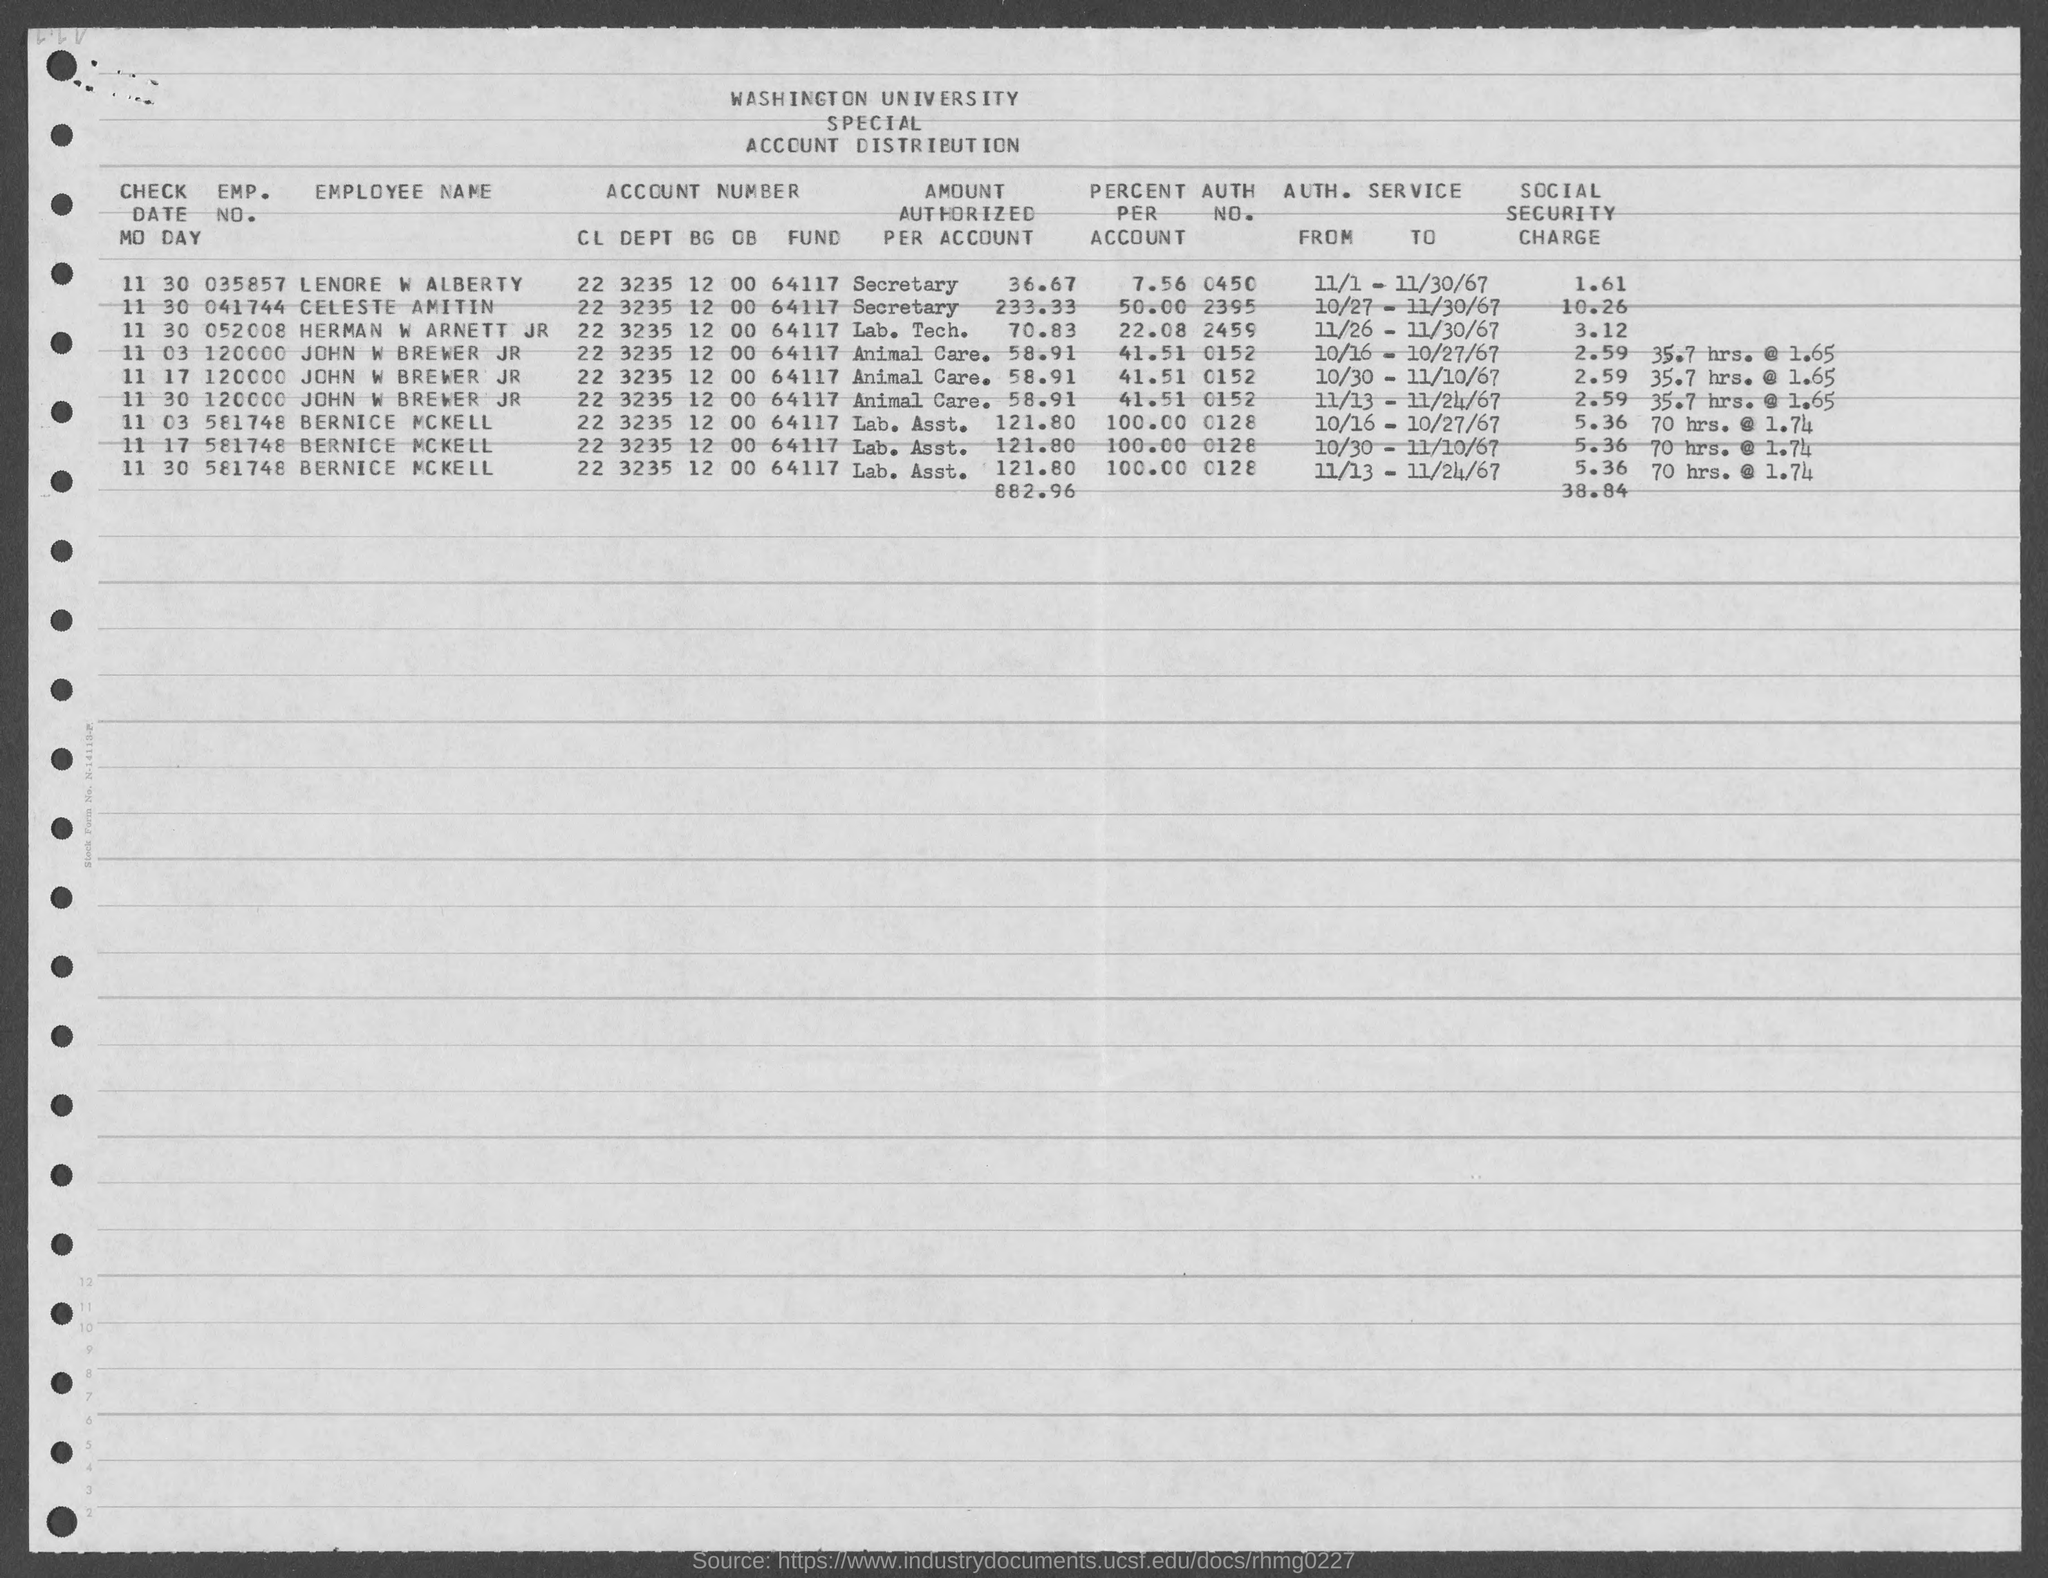Outline some significant characteristics in this image. The emp. no. of Bernice McKell is 581748. The identity number of Celeste Amitin is 041744. John W Brewer Jr has an employment number of 120,000. The authoritative number for John W. Brewer Jr. is 0152. The author of the text is asking for the identification number of a person named Lenore W Alberty. 